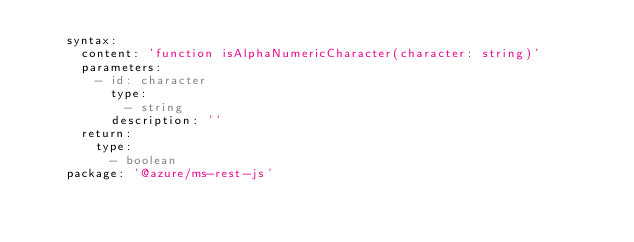Convert code to text. <code><loc_0><loc_0><loc_500><loc_500><_YAML_>    syntax:
      content: 'function isAlphaNumericCharacter(character: string)'
      parameters:
        - id: character
          type:
            - string
          description: ''
      return:
        type:
          - boolean
    package: '@azure/ms-rest-js'</code> 